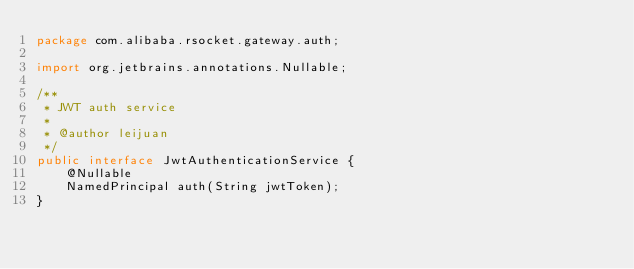Convert code to text. <code><loc_0><loc_0><loc_500><loc_500><_Java_>package com.alibaba.rsocket.gateway.auth;

import org.jetbrains.annotations.Nullable;

/**
 * JWT auth service
 *
 * @author leijuan
 */
public interface JwtAuthenticationService {
    @Nullable
    NamedPrincipal auth(String jwtToken);
}
</code> 